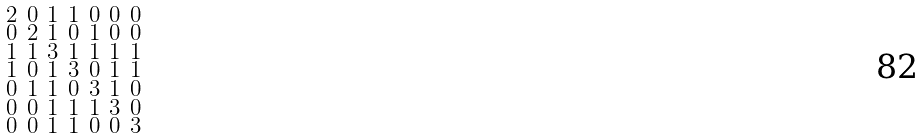Convert formula to latex. <formula><loc_0><loc_0><loc_500><loc_500>\begin{smallmatrix} 2 & 0 & 1 & 1 & 0 & 0 & 0 \\ 0 & 2 & 1 & 0 & 1 & 0 & 0 \\ 1 & 1 & 3 & 1 & 1 & 1 & 1 \\ 1 & 0 & 1 & 3 & 0 & 1 & 1 \\ 0 & 1 & 1 & 0 & 3 & 1 & 0 \\ 0 & 0 & 1 & 1 & 1 & 3 & 0 \\ 0 & 0 & 1 & 1 & 0 & 0 & 3 \end{smallmatrix}</formula> 